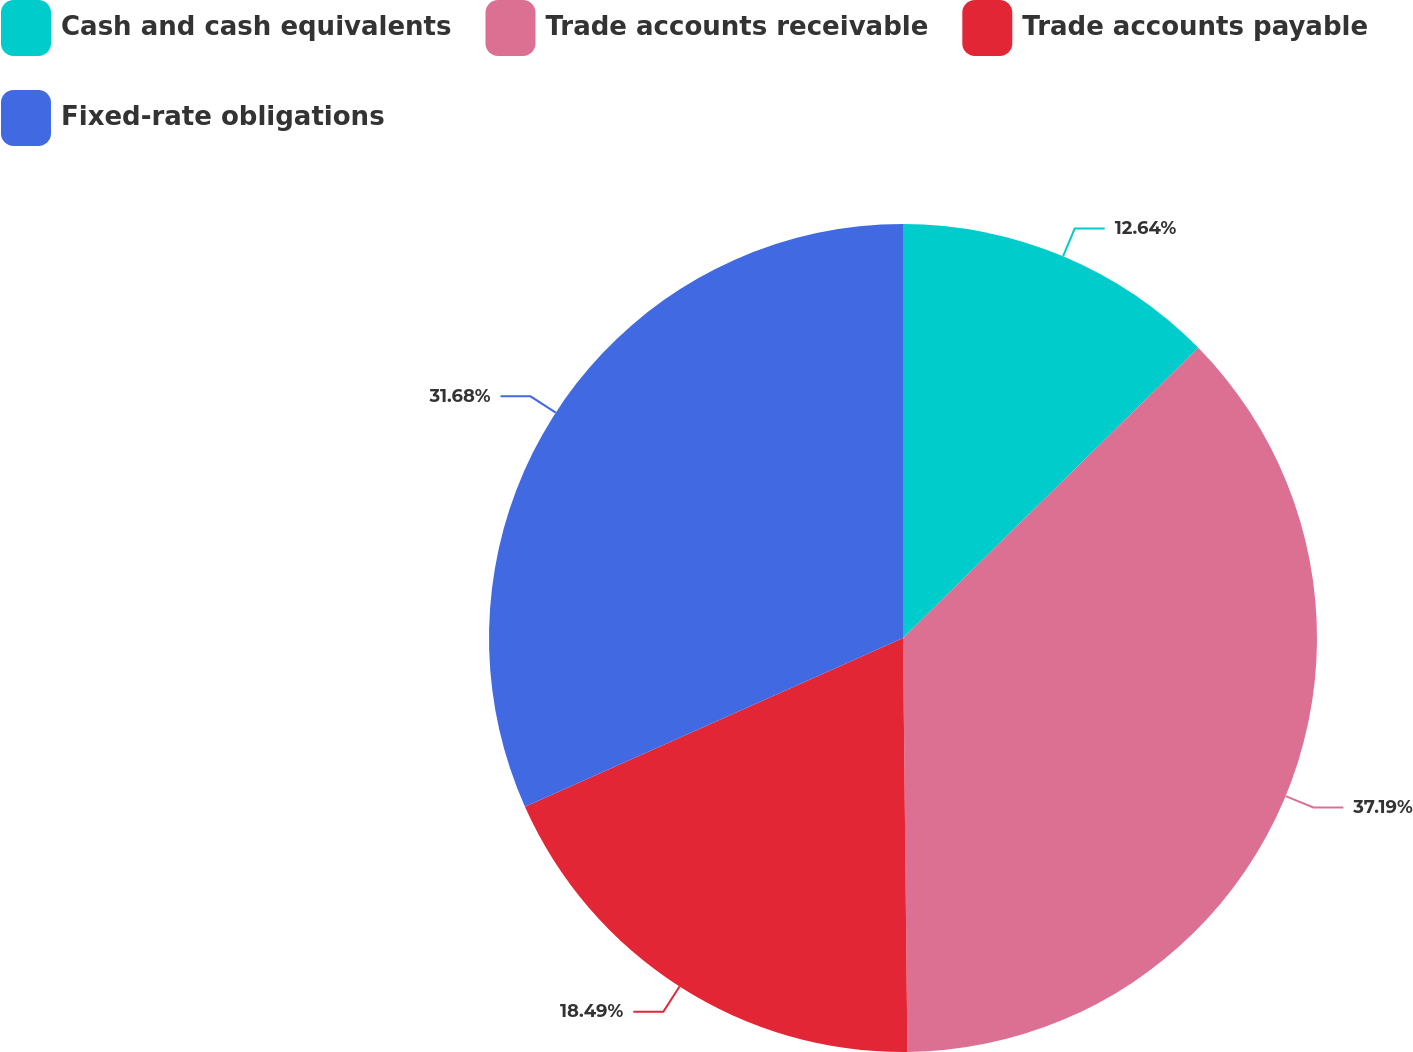<chart> <loc_0><loc_0><loc_500><loc_500><pie_chart><fcel>Cash and cash equivalents<fcel>Trade accounts receivable<fcel>Trade accounts payable<fcel>Fixed-rate obligations<nl><fcel>12.64%<fcel>37.19%<fcel>18.49%<fcel>31.68%<nl></chart> 